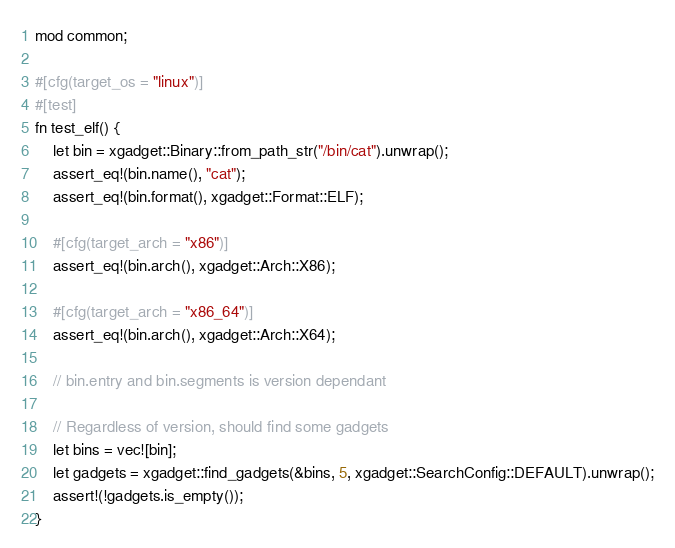Convert code to text. <code><loc_0><loc_0><loc_500><loc_500><_Rust_>mod common;

#[cfg(target_os = "linux")]
#[test]
fn test_elf() {
    let bin = xgadget::Binary::from_path_str("/bin/cat").unwrap();
    assert_eq!(bin.name(), "cat");
    assert_eq!(bin.format(), xgadget::Format::ELF);

    #[cfg(target_arch = "x86")]
    assert_eq!(bin.arch(), xgadget::Arch::X86);

    #[cfg(target_arch = "x86_64")]
    assert_eq!(bin.arch(), xgadget::Arch::X64);

    // bin.entry and bin.segments is version dependant

    // Regardless of version, should find some gadgets
    let bins = vec![bin];
    let gadgets = xgadget::find_gadgets(&bins, 5, xgadget::SearchConfig::DEFAULT).unwrap();
    assert!(!gadgets.is_empty());
}
</code> 